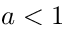Convert formula to latex. <formula><loc_0><loc_0><loc_500><loc_500>a < 1</formula> 